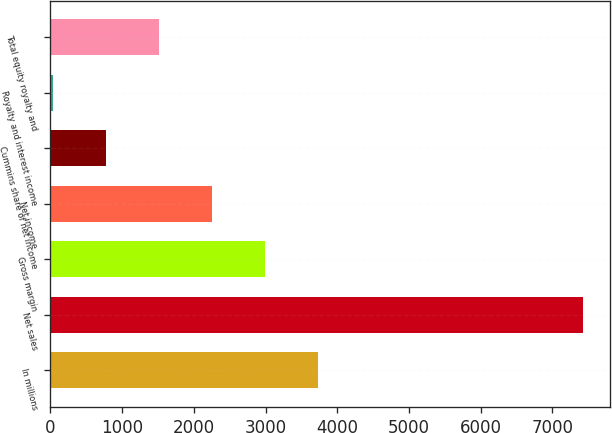Convert chart to OTSL. <chart><loc_0><loc_0><loc_500><loc_500><bar_chart><fcel>In millions<fcel>Net sales<fcel>Gross margin<fcel>Net income<fcel>Cummins share of net income<fcel>Royalty and interest income<fcel>Total equity royalty and<nl><fcel>3733<fcel>7426<fcel>2994.4<fcel>2255.8<fcel>778.6<fcel>40<fcel>1517.2<nl></chart> 